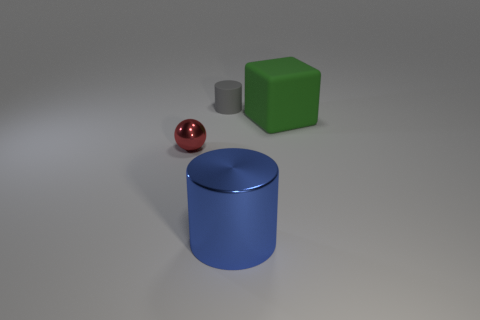There is a cylinder that is in front of the small gray rubber cylinder; what is its color?
Your answer should be compact. Blue. Is there a small shiny thing right of the cylinder that is in front of the tiny red metal sphere?
Ensure brevity in your answer.  No. Does the cylinder in front of the large rubber cube have the same color as the metal thing on the left side of the large metallic cylinder?
Provide a short and direct response. No. How many small things are behind the small red metal thing?
Give a very brief answer. 1. Is the cylinder in front of the large green matte cube made of the same material as the green cube?
Provide a succinct answer. No. How many brown blocks are the same material as the big green block?
Provide a succinct answer. 0. Are there more objects that are behind the small red metal sphere than green cubes?
Your answer should be very brief. Yes. Is there another green thing that has the same shape as the small rubber thing?
Your answer should be compact. No. How many things are either large blue metal cylinders or gray objects?
Your answer should be compact. 2. There is a large thing in front of the tiny red shiny sphere in front of the gray rubber thing; how many small red balls are to the right of it?
Ensure brevity in your answer.  0. 